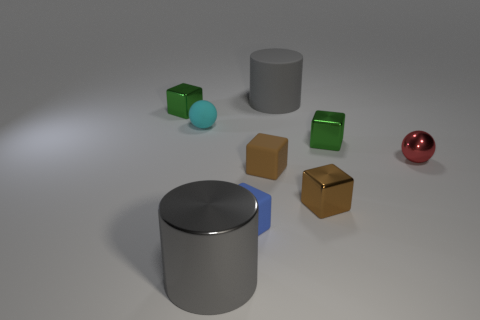There is a green object in front of the metal thing that is left of the big gray object in front of the large gray matte cylinder; what is its shape?
Offer a very short reply. Cube. How many cylinders are behind the tiny green metal cube to the left of the gray shiny object?
Your answer should be very brief. 1. Is the material of the small cyan sphere the same as the tiny blue thing?
Give a very brief answer. Yes. What number of small red metal objects are in front of the sphere on the left side of the red ball right of the blue cube?
Provide a succinct answer. 1. There is a tiny ball that is to the left of the tiny red shiny sphere; what color is it?
Give a very brief answer. Cyan. What is the shape of the large thing that is behind the small green metal cube that is on the left side of the gray metallic thing?
Keep it short and to the point. Cylinder. Is the small matte ball the same color as the tiny metal ball?
Provide a short and direct response. No. What number of cylinders are tiny matte things or brown metallic things?
Offer a terse response. 0. What material is the thing that is both behind the tiny rubber sphere and in front of the big gray rubber cylinder?
Keep it short and to the point. Metal. How many gray metal cylinders are behind the large rubber cylinder?
Your response must be concise. 0. 